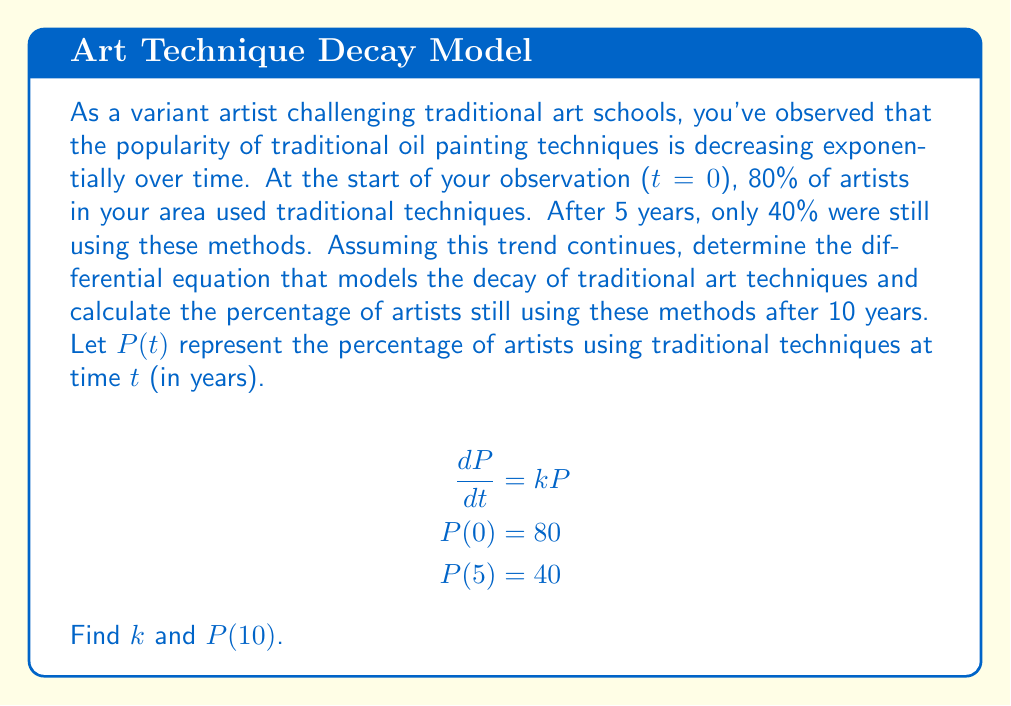Teach me how to tackle this problem. To solve this problem, we'll follow these steps:

1) We're given the differential equation: 
   $$\frac{dP}{dt} = kP$$
   This is a first-order linear differential equation representing exponential decay.

2) The general solution to this equation is:
   $$P(t) = Ce^{kt}$$
   where C is a constant we need to determine.

3) Using the initial condition P(0) = 80:
   $$80 = Ce^{k(0)} = C$$

4) So our specific solution is:
   $$P(t) = 80e^{kt}$$

5) Now we can use the condition P(5) = 40 to find k:
   $$40 = 80e^{k(5)}$$
   $$\frac{1}{2} = e^{5k}$$
   $$\ln(\frac{1}{2}) = 5k$$
   $$k = \frac{\ln(1/2)}{5} = -\frac{\ln(2)}{5} \approx -0.1386$$

6) Now that we have k, we can find P(10):
   $$P(10) = 80e^{(-\ln(2)/5)(10)}$$
   $$= 80(e^{-\ln(2)})^2$$
   $$= 80(\frac{1}{2})^2$$
   $$= 80 \cdot \frac{1}{4} = 20$$

Therefore, after 10 years, 20% of artists will still be using traditional techniques.
Answer: k = -ln(2)/5, P(10) = 20% 